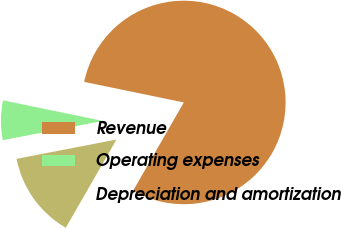Convert chart. <chart><loc_0><loc_0><loc_500><loc_500><pie_chart><fcel>Revenue<fcel>Operating expenses<fcel>Depreciation and amortization<nl><fcel>80.06%<fcel>6.28%<fcel>13.66%<nl></chart> 